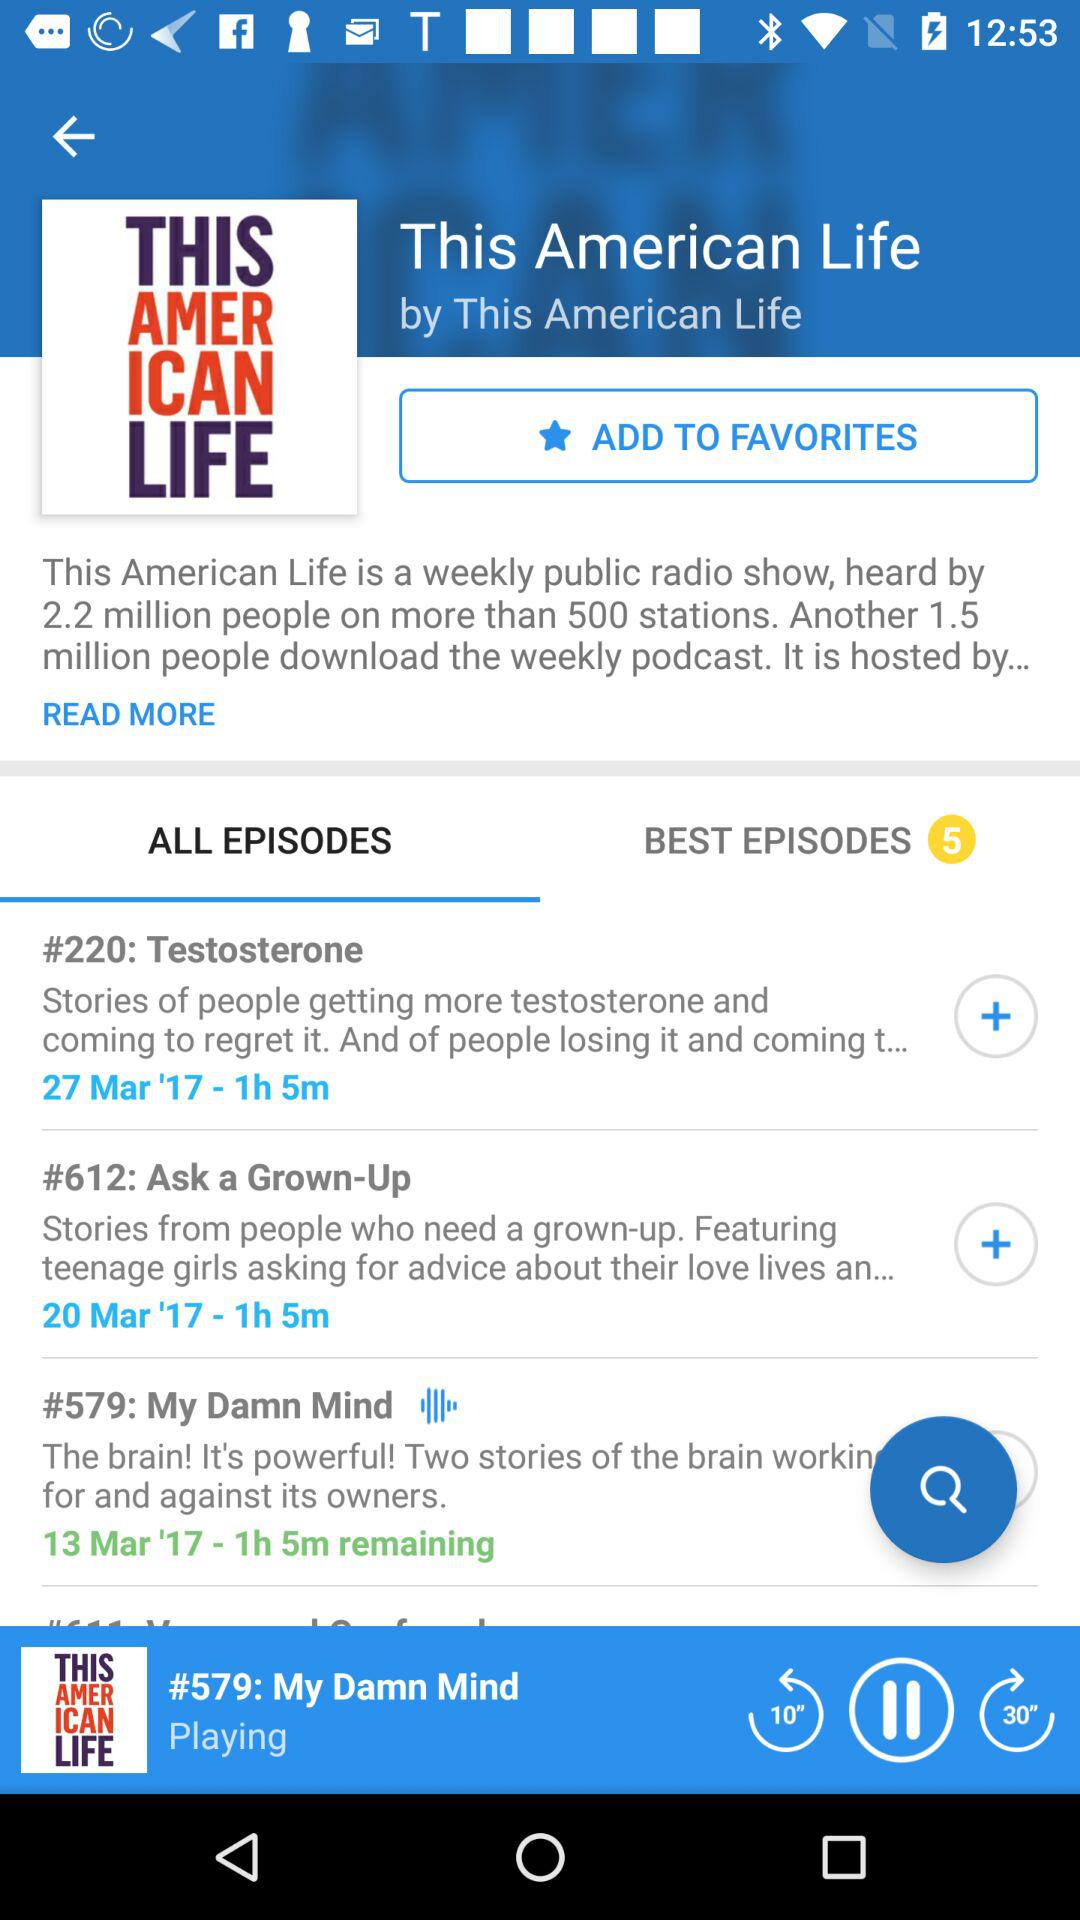How many best episodes are there? There are 5 best episodes. 